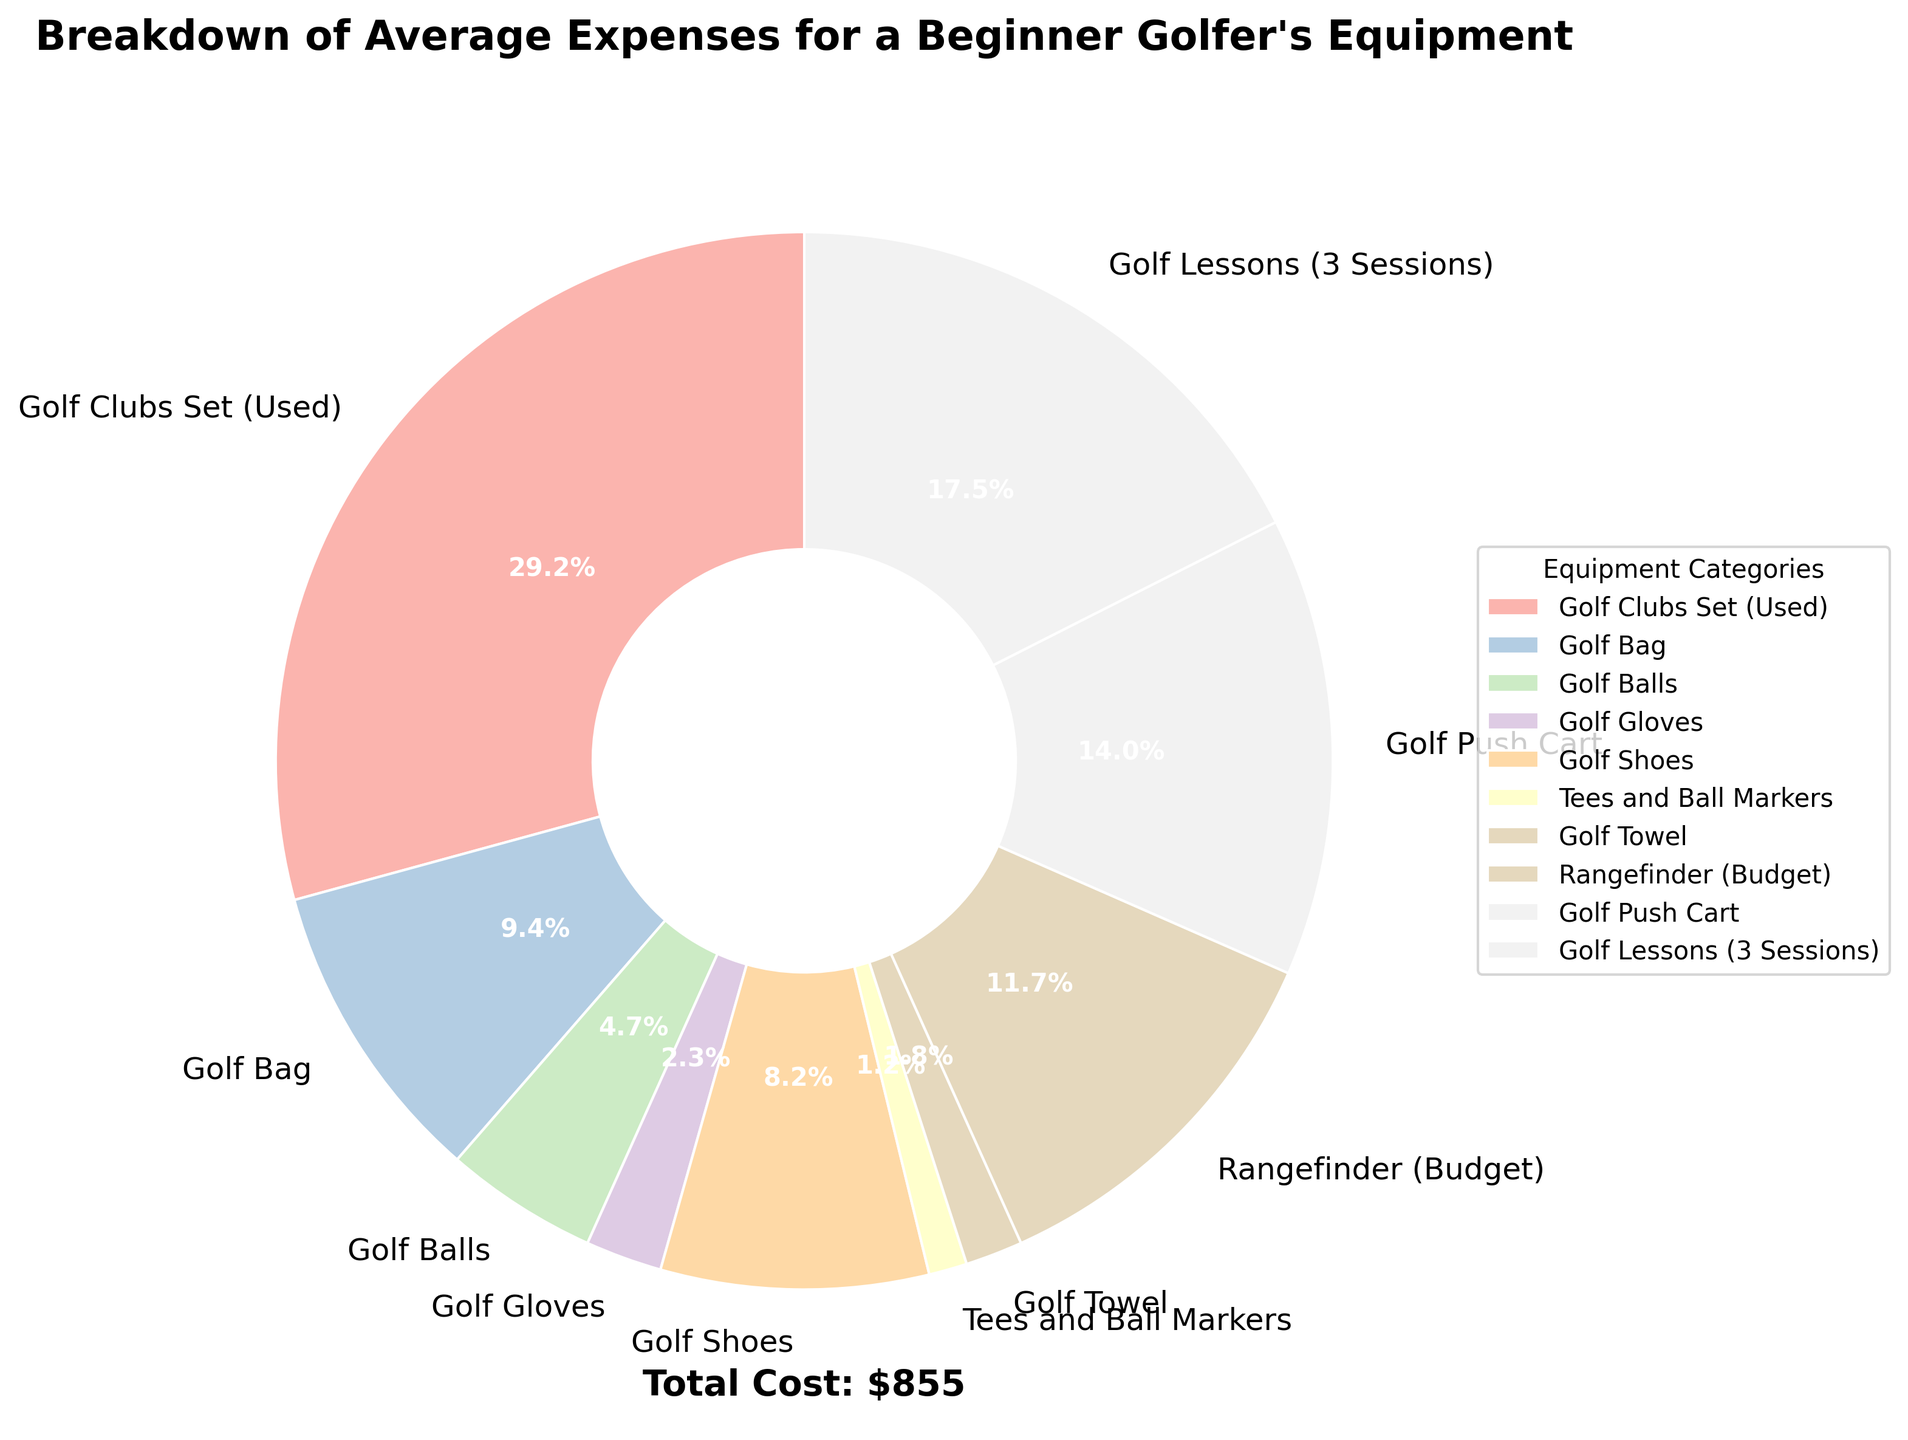Which category has the highest cost? By looking at the pie chart, we can see which section represents the largest portion of the pie. It’s the largest wedge on the chart.
Answer: Golf Clubs Set (Used) What percentage of the total cost is spent on Golf Clubs Set (Used)? The percentage of cost for each category is displayed near each wedge. For the Golf Clubs Set (Used), this specific percentage can be read directly from the pie chart.
Answer: 34.4% What is the combined cost of Golf Bag and Golf Shoes? First, find the respective costs for Golf Bag and Golf Shoes from the chart. Then, add these costs together: $80 (Golf Bag) + $70 (Golf Shoes) = $150.
Answer: $150 Does the cost of Golf Lessons (3 Sessions) and Golf Push Cart together exceed the cost of Golf Clubs Set (Used)? Calculate the total cost of Golf Lessons (3 Sessions) and Golf Push Cart: $150 + $120 = $270. Compare this with the cost of Golf Clubs Set (Used), which is $250. Since $270 > $250, the combined cost exceeds that of Golf Clubs Set.
Answer: Yes Which two categories have the smallest expenses, and what are their combined percentages? From the pie chart, identify the two smallest wedges, which are Tees and Ball Markers and Golf Towel. Their respective percentages are 1.4% and 2.1%. Adding these together: 1.4% + 2.1% = 3.5%.
Answer: Tees and Ball Markers, Golf Towel; 3.5% How do the costs of Rangefinder (Budget) and Golf Lessons (3 Sessions) compare? Examine the chart to see the costs for Rangefinder (Budget) and Golf Lessons (3 Sessions). They are $100 and $150, respectively. Since $150 > $100, Golf Lessons (3 Sessions) cost more.
Answer: Golf Lessons (3 Sessions) cost more What is the visual representation (color) of the Golf Gloves category in the pie chart? Look at the pie chart and identify the color of the wedge labeled Golf Gloves. The color palette used is from matplotlib's Pastel1 collection.
Answer: A pastel shade (pink) If the total cost is $855, what is the cost percentage attributed to the Golf Push Cart? First, find the cost of the Golf Push Cart from the data. Then, use the formula: (Cost of Golf Push Cart / Total Cost) x 100: ($120 / $855) x 100 = 14% approximately.
Answer: 14% What is the difference in expenditure between Golf Gloves and Golf Balls? Find the costs of Golf Gloves ($20) and Golf Balls ($40) from the pie chart. Subtract the smaller cost from the larger: $40 - $20 = $20.
Answer: $20 Which expense category is directly responsible for about one-ninth of the total cost? A percentage near to 11% (approximately one-ninth) should be identified. Looking at the pie chart, the closest percentage is for Golf Lessons (3 Sessions) at 17.5%.
Answer: Golf Lessons (3 Sessions) 